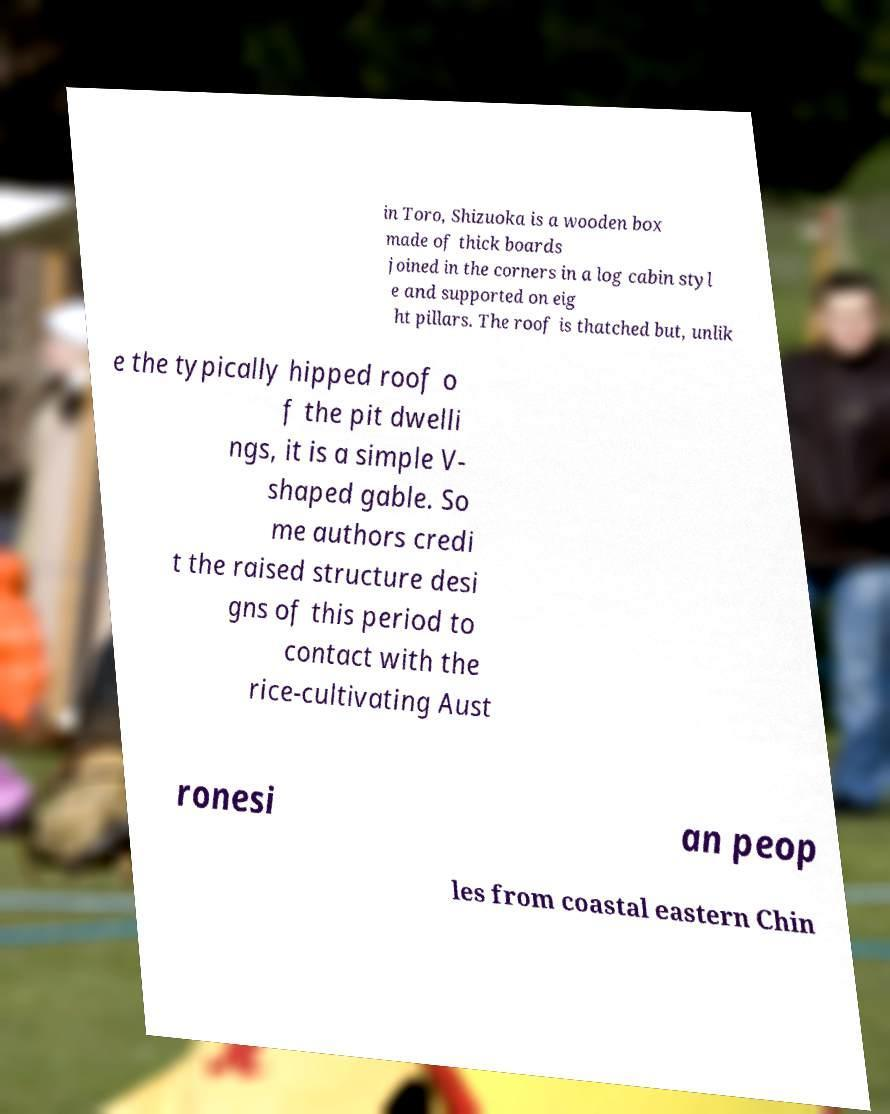Can you read and provide the text displayed in the image?This photo seems to have some interesting text. Can you extract and type it out for me? in Toro, Shizuoka is a wooden box made of thick boards joined in the corners in a log cabin styl e and supported on eig ht pillars. The roof is thatched but, unlik e the typically hipped roof o f the pit dwelli ngs, it is a simple V- shaped gable. So me authors credi t the raised structure desi gns of this period to contact with the rice-cultivating Aust ronesi an peop les from coastal eastern Chin 